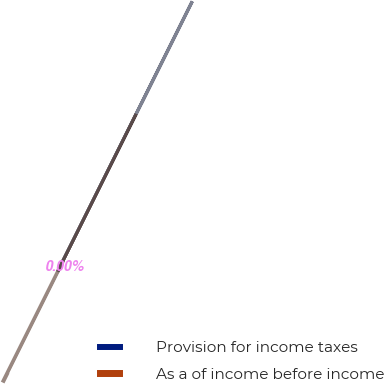<chart> <loc_0><loc_0><loc_500><loc_500><pie_chart><fcel>Provision for income taxes<fcel>As a of income before income<nl><fcel>100.0%<fcel>0.0%<nl></chart> 